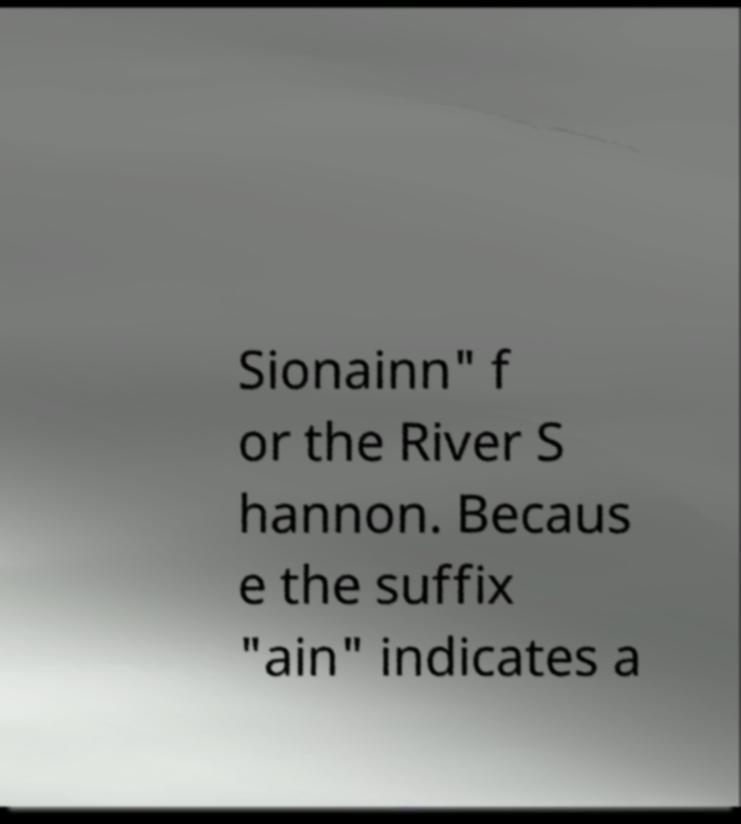Could you extract and type out the text from this image? Sionainn" f or the River S hannon. Becaus e the suffix "ain" indicates a 